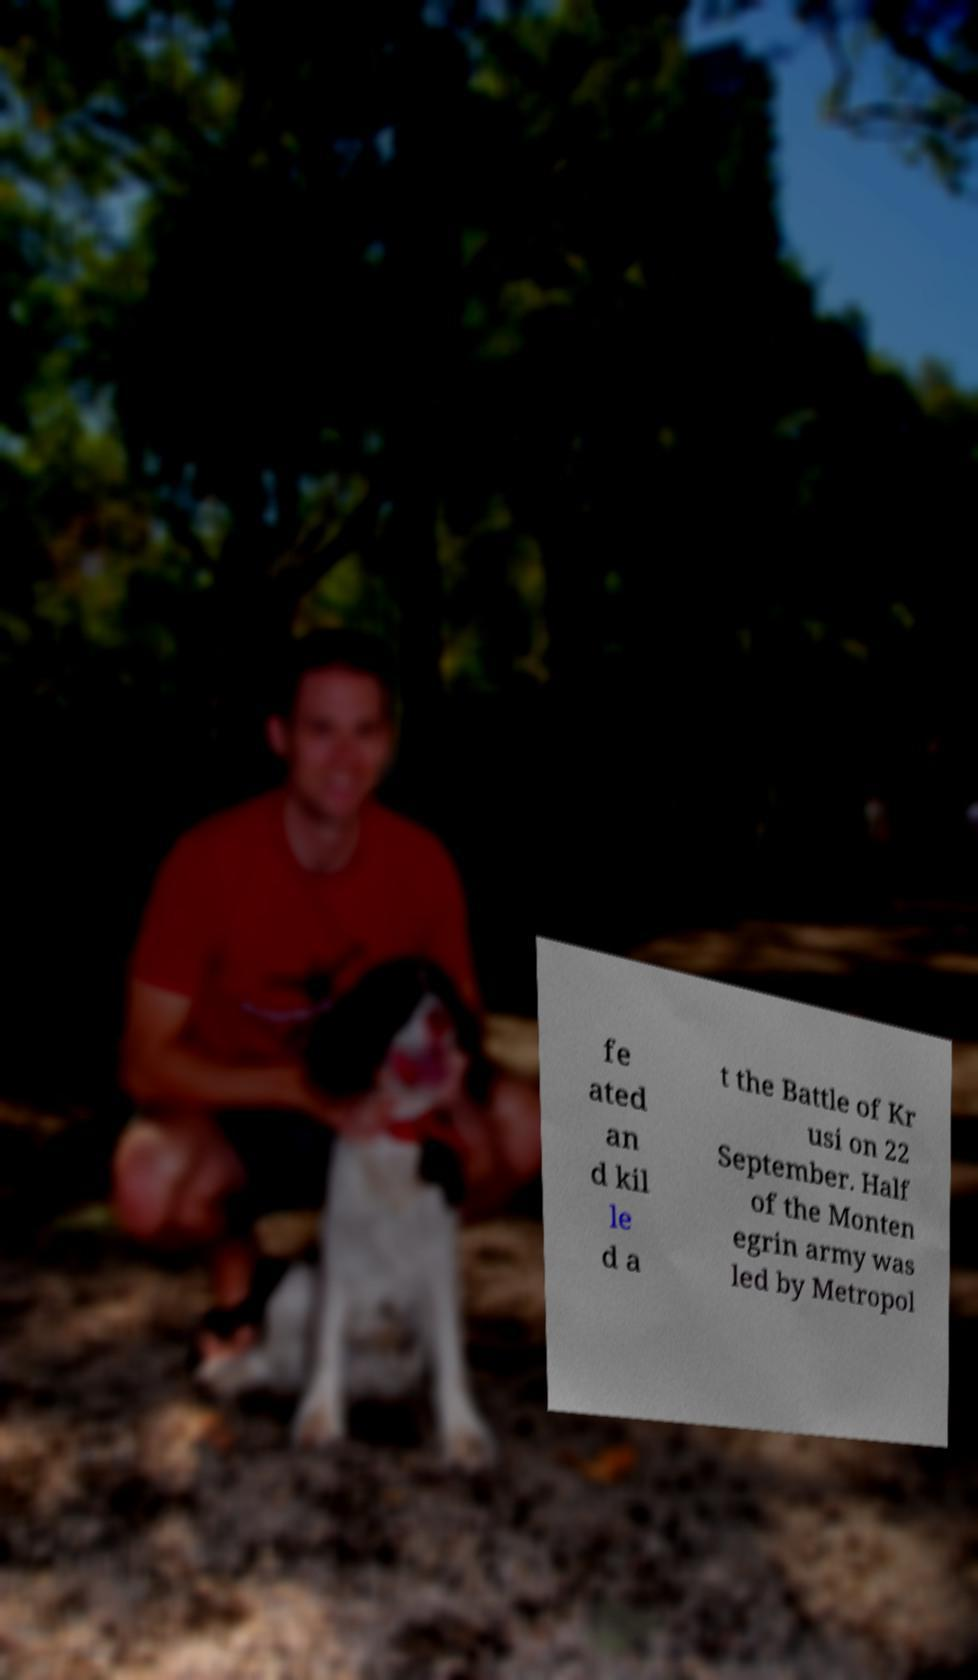There's text embedded in this image that I need extracted. Can you transcribe it verbatim? fe ated an d kil le d a t the Battle of Kr usi on 22 September. Half of the Monten egrin army was led by Metropol 